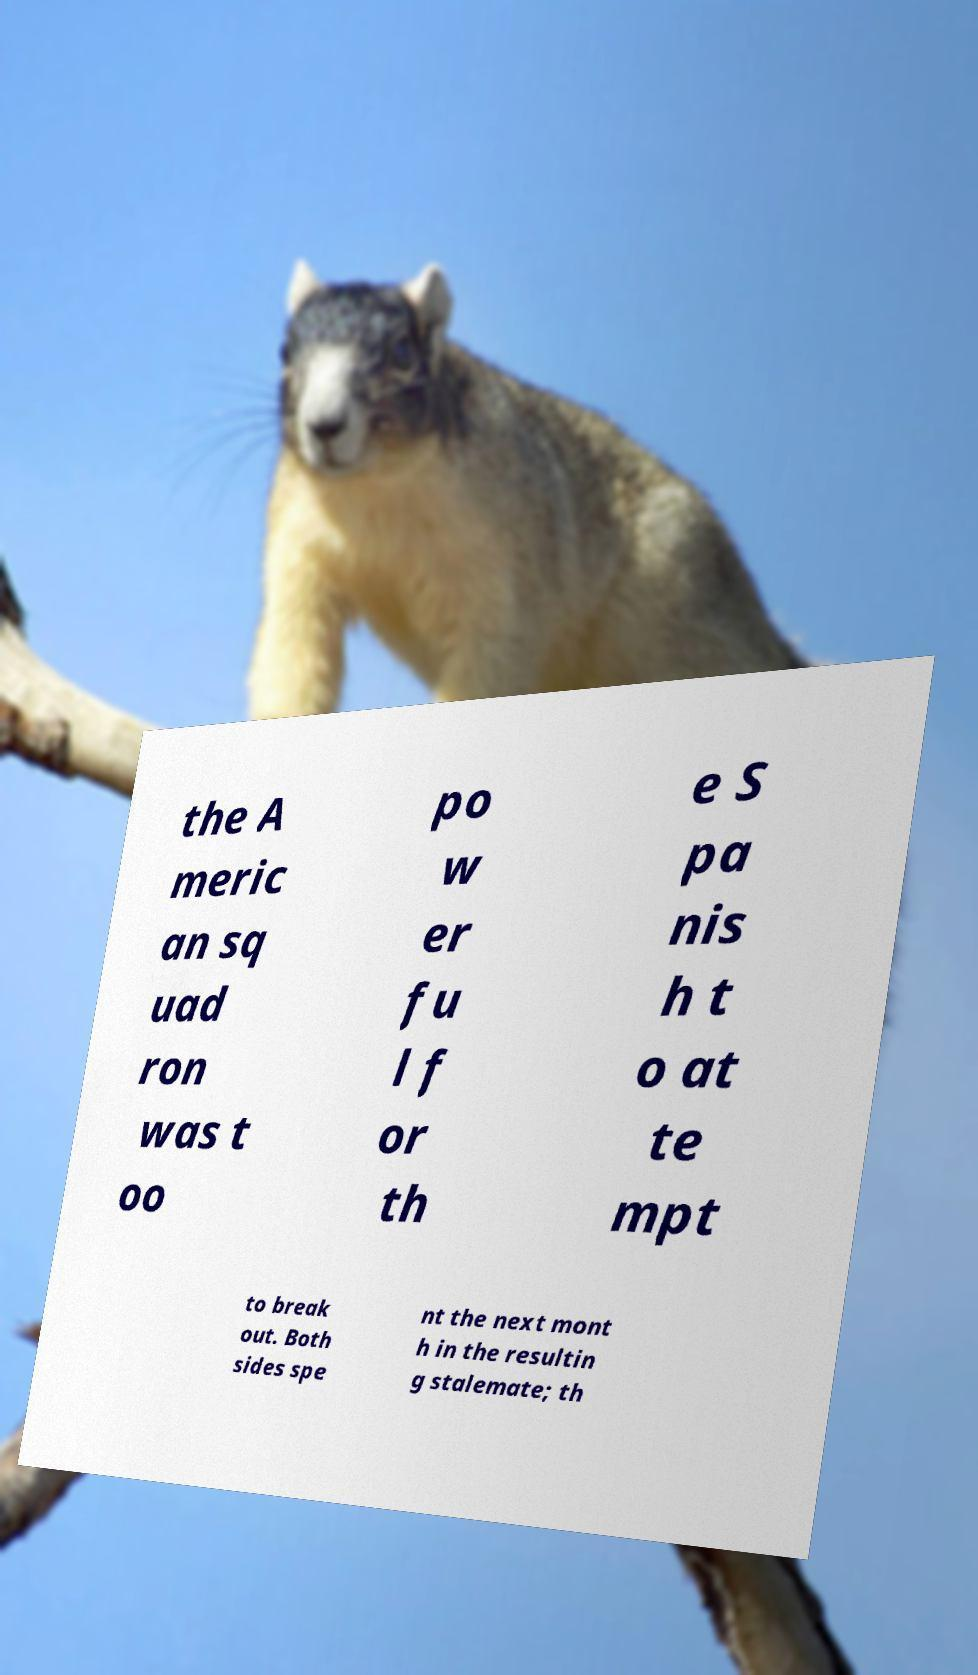Could you assist in decoding the text presented in this image and type it out clearly? the A meric an sq uad ron was t oo po w er fu l f or th e S pa nis h t o at te mpt to break out. Both sides spe nt the next mont h in the resultin g stalemate; th 